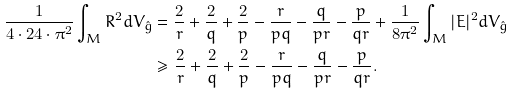<formula> <loc_0><loc_0><loc_500><loc_500>\frac { 1 } { 4 \cdot 2 4 \cdot \pi ^ { 2 } } \int _ { M } R ^ { 2 } d V _ { \hat { g } } & = \frac { 2 } { r } + \frac { 2 } { q } + \frac { 2 } { p } - \frac { r } { p q } - \frac { q } { p r } - \frac { p } { q r } + \frac { 1 } { 8 \pi ^ { 2 } } \int _ { M } | E | ^ { 2 } d V _ { \hat { g } } \\ & \geq \frac { 2 } { r } + \frac { 2 } { q } + \frac { 2 } { p } - \frac { r } { p q } - \frac { q } { p r } - \frac { p } { q r } .</formula> 